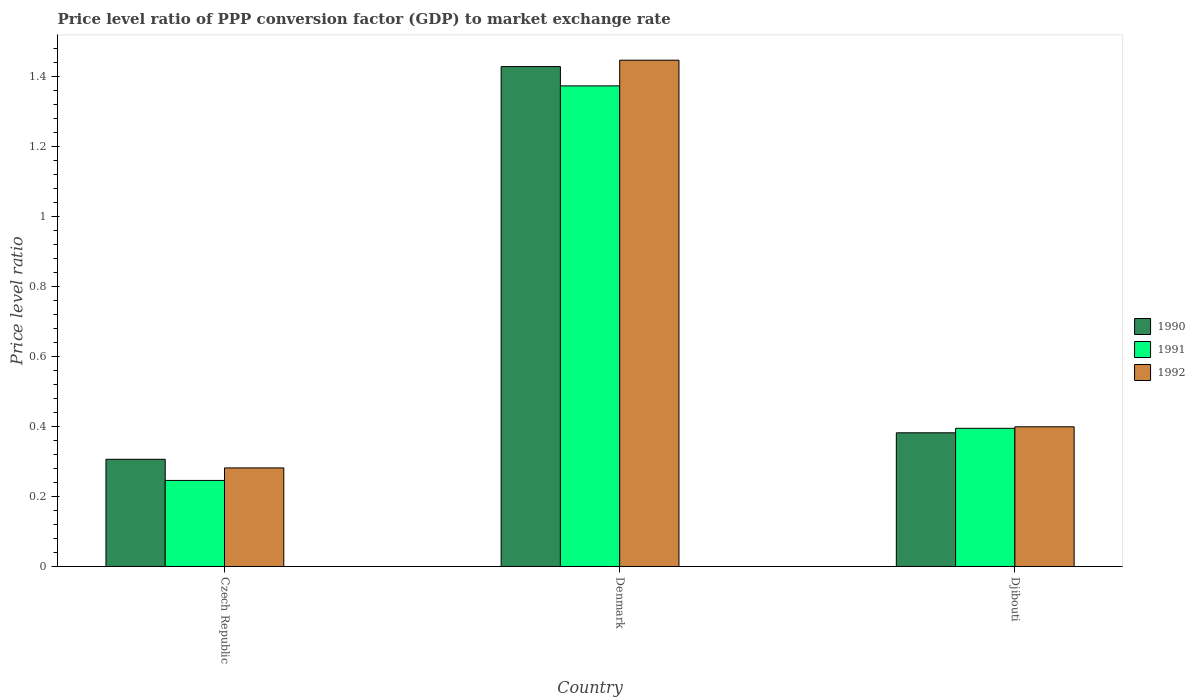How many groups of bars are there?
Offer a terse response. 3. Are the number of bars per tick equal to the number of legend labels?
Your response must be concise. Yes. Are the number of bars on each tick of the X-axis equal?
Offer a very short reply. Yes. How many bars are there on the 1st tick from the left?
Provide a short and direct response. 3. How many bars are there on the 2nd tick from the right?
Keep it short and to the point. 3. What is the label of the 3rd group of bars from the left?
Offer a very short reply. Djibouti. In how many cases, is the number of bars for a given country not equal to the number of legend labels?
Provide a succinct answer. 0. What is the price level ratio in 1991 in Czech Republic?
Your answer should be very brief. 0.25. Across all countries, what is the maximum price level ratio in 1991?
Make the answer very short. 1.37. Across all countries, what is the minimum price level ratio in 1990?
Provide a succinct answer. 0.31. In which country was the price level ratio in 1991 minimum?
Offer a terse response. Czech Republic. What is the total price level ratio in 1992 in the graph?
Offer a terse response. 2.13. What is the difference between the price level ratio in 1991 in Czech Republic and that in Denmark?
Your answer should be compact. -1.13. What is the difference between the price level ratio in 1992 in Denmark and the price level ratio in 1990 in Czech Republic?
Your answer should be very brief. 1.14. What is the average price level ratio in 1992 per country?
Provide a succinct answer. 0.71. What is the difference between the price level ratio of/in 1990 and price level ratio of/in 1991 in Czech Republic?
Provide a short and direct response. 0.06. In how many countries, is the price level ratio in 1992 greater than 0.9600000000000001?
Keep it short and to the point. 1. What is the ratio of the price level ratio in 1992 in Czech Republic to that in Djibouti?
Make the answer very short. 0.71. Is the price level ratio in 1990 in Czech Republic less than that in Denmark?
Give a very brief answer. Yes. Is the difference between the price level ratio in 1990 in Denmark and Djibouti greater than the difference between the price level ratio in 1991 in Denmark and Djibouti?
Your answer should be compact. Yes. What is the difference between the highest and the second highest price level ratio in 1990?
Keep it short and to the point. -1.05. What is the difference between the highest and the lowest price level ratio in 1990?
Keep it short and to the point. 1.12. In how many countries, is the price level ratio in 1992 greater than the average price level ratio in 1992 taken over all countries?
Keep it short and to the point. 1. Is the sum of the price level ratio in 1990 in Denmark and Djibouti greater than the maximum price level ratio in 1991 across all countries?
Your answer should be very brief. Yes. What does the 3rd bar from the left in Denmark represents?
Your answer should be compact. 1992. What does the 2nd bar from the right in Djibouti represents?
Offer a very short reply. 1991. Are all the bars in the graph horizontal?
Your answer should be very brief. No. How many countries are there in the graph?
Make the answer very short. 3. Are the values on the major ticks of Y-axis written in scientific E-notation?
Keep it short and to the point. No. Where does the legend appear in the graph?
Provide a short and direct response. Center right. How many legend labels are there?
Offer a terse response. 3. What is the title of the graph?
Provide a succinct answer. Price level ratio of PPP conversion factor (GDP) to market exchange rate. Does "1995" appear as one of the legend labels in the graph?
Offer a very short reply. No. What is the label or title of the X-axis?
Provide a short and direct response. Country. What is the label or title of the Y-axis?
Provide a short and direct response. Price level ratio. What is the Price level ratio of 1990 in Czech Republic?
Your answer should be very brief. 0.31. What is the Price level ratio of 1991 in Czech Republic?
Your response must be concise. 0.25. What is the Price level ratio of 1992 in Czech Republic?
Provide a succinct answer. 0.28. What is the Price level ratio of 1990 in Denmark?
Offer a terse response. 1.43. What is the Price level ratio of 1991 in Denmark?
Your answer should be very brief. 1.37. What is the Price level ratio in 1992 in Denmark?
Make the answer very short. 1.45. What is the Price level ratio of 1990 in Djibouti?
Your response must be concise. 0.38. What is the Price level ratio in 1991 in Djibouti?
Give a very brief answer. 0.4. What is the Price level ratio of 1992 in Djibouti?
Your answer should be very brief. 0.4. Across all countries, what is the maximum Price level ratio of 1990?
Give a very brief answer. 1.43. Across all countries, what is the maximum Price level ratio of 1991?
Your response must be concise. 1.37. Across all countries, what is the maximum Price level ratio of 1992?
Provide a succinct answer. 1.45. Across all countries, what is the minimum Price level ratio of 1990?
Offer a very short reply. 0.31. Across all countries, what is the minimum Price level ratio in 1991?
Offer a terse response. 0.25. Across all countries, what is the minimum Price level ratio in 1992?
Offer a very short reply. 0.28. What is the total Price level ratio in 1990 in the graph?
Offer a very short reply. 2.12. What is the total Price level ratio in 1991 in the graph?
Your answer should be compact. 2.02. What is the total Price level ratio of 1992 in the graph?
Give a very brief answer. 2.13. What is the difference between the Price level ratio in 1990 in Czech Republic and that in Denmark?
Provide a succinct answer. -1.12. What is the difference between the Price level ratio in 1991 in Czech Republic and that in Denmark?
Give a very brief answer. -1.13. What is the difference between the Price level ratio in 1992 in Czech Republic and that in Denmark?
Ensure brevity in your answer.  -1.17. What is the difference between the Price level ratio of 1990 in Czech Republic and that in Djibouti?
Give a very brief answer. -0.08. What is the difference between the Price level ratio of 1991 in Czech Republic and that in Djibouti?
Give a very brief answer. -0.15. What is the difference between the Price level ratio of 1992 in Czech Republic and that in Djibouti?
Keep it short and to the point. -0.12. What is the difference between the Price level ratio in 1990 in Denmark and that in Djibouti?
Make the answer very short. 1.05. What is the difference between the Price level ratio of 1991 in Denmark and that in Djibouti?
Ensure brevity in your answer.  0.98. What is the difference between the Price level ratio of 1992 in Denmark and that in Djibouti?
Ensure brevity in your answer.  1.05. What is the difference between the Price level ratio of 1990 in Czech Republic and the Price level ratio of 1991 in Denmark?
Offer a very short reply. -1.07. What is the difference between the Price level ratio of 1990 in Czech Republic and the Price level ratio of 1992 in Denmark?
Ensure brevity in your answer.  -1.14. What is the difference between the Price level ratio of 1991 in Czech Republic and the Price level ratio of 1992 in Denmark?
Give a very brief answer. -1.2. What is the difference between the Price level ratio in 1990 in Czech Republic and the Price level ratio in 1991 in Djibouti?
Make the answer very short. -0.09. What is the difference between the Price level ratio in 1990 in Czech Republic and the Price level ratio in 1992 in Djibouti?
Offer a terse response. -0.09. What is the difference between the Price level ratio in 1991 in Czech Republic and the Price level ratio in 1992 in Djibouti?
Keep it short and to the point. -0.15. What is the difference between the Price level ratio of 1990 in Denmark and the Price level ratio of 1991 in Djibouti?
Your answer should be compact. 1.03. What is the difference between the Price level ratio of 1990 in Denmark and the Price level ratio of 1992 in Djibouti?
Ensure brevity in your answer.  1.03. What is the difference between the Price level ratio of 1991 in Denmark and the Price level ratio of 1992 in Djibouti?
Ensure brevity in your answer.  0.97. What is the average Price level ratio of 1990 per country?
Ensure brevity in your answer.  0.71. What is the average Price level ratio in 1991 per country?
Offer a terse response. 0.67. What is the average Price level ratio of 1992 per country?
Provide a short and direct response. 0.71. What is the difference between the Price level ratio of 1990 and Price level ratio of 1991 in Czech Republic?
Make the answer very short. 0.06. What is the difference between the Price level ratio of 1990 and Price level ratio of 1992 in Czech Republic?
Offer a very short reply. 0.02. What is the difference between the Price level ratio in 1991 and Price level ratio in 1992 in Czech Republic?
Provide a succinct answer. -0.04. What is the difference between the Price level ratio in 1990 and Price level ratio in 1991 in Denmark?
Ensure brevity in your answer.  0.06. What is the difference between the Price level ratio of 1990 and Price level ratio of 1992 in Denmark?
Your answer should be compact. -0.02. What is the difference between the Price level ratio in 1991 and Price level ratio in 1992 in Denmark?
Offer a terse response. -0.07. What is the difference between the Price level ratio in 1990 and Price level ratio in 1991 in Djibouti?
Offer a very short reply. -0.01. What is the difference between the Price level ratio in 1990 and Price level ratio in 1992 in Djibouti?
Provide a short and direct response. -0.02. What is the difference between the Price level ratio in 1991 and Price level ratio in 1992 in Djibouti?
Give a very brief answer. -0. What is the ratio of the Price level ratio in 1990 in Czech Republic to that in Denmark?
Your response must be concise. 0.21. What is the ratio of the Price level ratio of 1991 in Czech Republic to that in Denmark?
Provide a short and direct response. 0.18. What is the ratio of the Price level ratio of 1992 in Czech Republic to that in Denmark?
Provide a succinct answer. 0.19. What is the ratio of the Price level ratio in 1990 in Czech Republic to that in Djibouti?
Offer a terse response. 0.8. What is the ratio of the Price level ratio of 1991 in Czech Republic to that in Djibouti?
Your answer should be compact. 0.62. What is the ratio of the Price level ratio of 1992 in Czech Republic to that in Djibouti?
Ensure brevity in your answer.  0.71. What is the ratio of the Price level ratio in 1990 in Denmark to that in Djibouti?
Provide a succinct answer. 3.74. What is the ratio of the Price level ratio in 1991 in Denmark to that in Djibouti?
Make the answer very short. 3.48. What is the ratio of the Price level ratio of 1992 in Denmark to that in Djibouti?
Provide a short and direct response. 3.62. What is the difference between the highest and the second highest Price level ratio of 1990?
Offer a very short reply. 1.05. What is the difference between the highest and the second highest Price level ratio of 1992?
Offer a very short reply. 1.05. What is the difference between the highest and the lowest Price level ratio of 1990?
Give a very brief answer. 1.12. What is the difference between the highest and the lowest Price level ratio in 1991?
Ensure brevity in your answer.  1.13. What is the difference between the highest and the lowest Price level ratio in 1992?
Your answer should be compact. 1.17. 